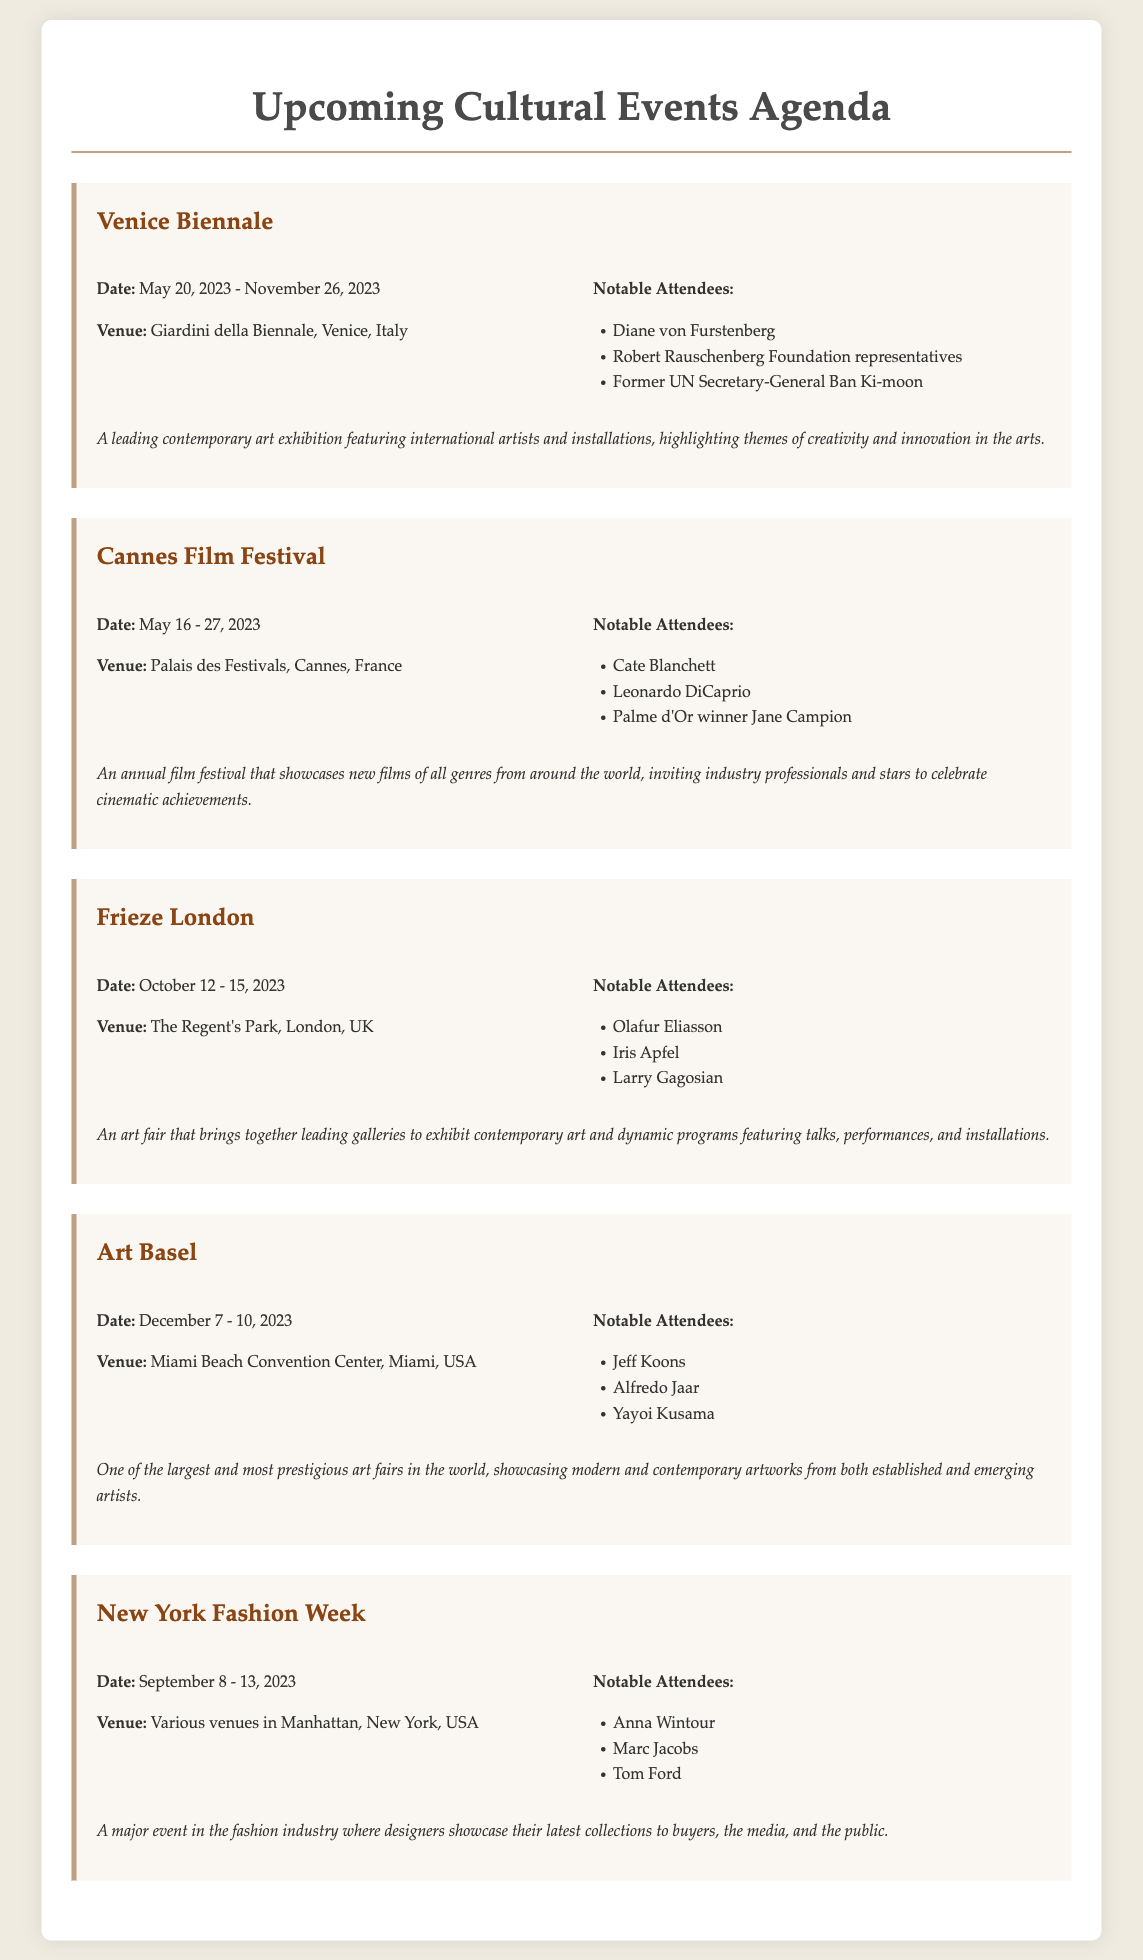What is the date range for the Venice Biennale? The date range is specified in the document as May 20, 2023 - November 26, 2023.
Answer: May 20, 2023 - November 26, 2023 Who is a notable attendee of the Cannes Film Festival? The document lists several notable attendees, one of whom is Cate Blanchett.
Answer: Cate Blanchett What venue will host Frieze London? The venue is mentioned in the document as The Regent's Park, London, UK.
Answer: The Regent's Park, London, UK When will Art Basel take place? The document specifies the dates for Art Basel as December 7 - 10, 2023.
Answer: December 7 - 10, 2023 Which event features Jeff Koons as a notable attendee? The document indicates that Jeff Koons is a notable attendee of Art Basel.
Answer: Art Basel What is the focus of New York Fashion Week? The focus is described in the document as showcasing designers' latest collections to buyers, the media, and the public.
Answer: Fashion industry How many notable attendees are mentioned for Frieze London? The document lists three notable attendees for Frieze London: Olafur Eliasson, Iris Apfel, and Larry Gagosian.
Answer: Three What type of event is the Cannes Film Festival? The document describes it as an annual film festival showcasing new films.
Answer: Film festival What is highlighted in the Venice Biennale? The document mentions themes of creativity and innovation in the arts are highlighted in the Venice Biennale.
Answer: Creativity and innovation in the arts 